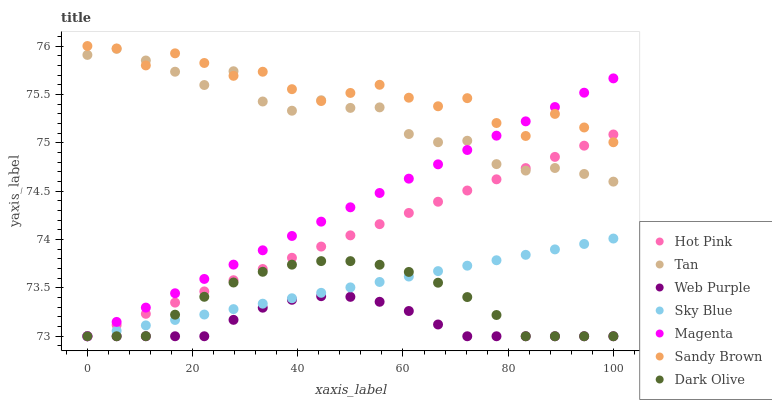Does Web Purple have the minimum area under the curve?
Answer yes or no. Yes. Does Sandy Brown have the maximum area under the curve?
Answer yes or no. Yes. Does Hot Pink have the minimum area under the curve?
Answer yes or no. No. Does Hot Pink have the maximum area under the curve?
Answer yes or no. No. Is Sky Blue the smoothest?
Answer yes or no. Yes. Is Sandy Brown the roughest?
Answer yes or no. Yes. Is Hot Pink the smoothest?
Answer yes or no. No. Is Hot Pink the roughest?
Answer yes or no. No. Does Dark Olive have the lowest value?
Answer yes or no. Yes. Does Tan have the lowest value?
Answer yes or no. No. Does Sandy Brown have the highest value?
Answer yes or no. Yes. Does Hot Pink have the highest value?
Answer yes or no. No. Is Web Purple less than Tan?
Answer yes or no. Yes. Is Sandy Brown greater than Web Purple?
Answer yes or no. Yes. Does Dark Olive intersect Magenta?
Answer yes or no. Yes. Is Dark Olive less than Magenta?
Answer yes or no. No. Is Dark Olive greater than Magenta?
Answer yes or no. No. Does Web Purple intersect Tan?
Answer yes or no. No. 